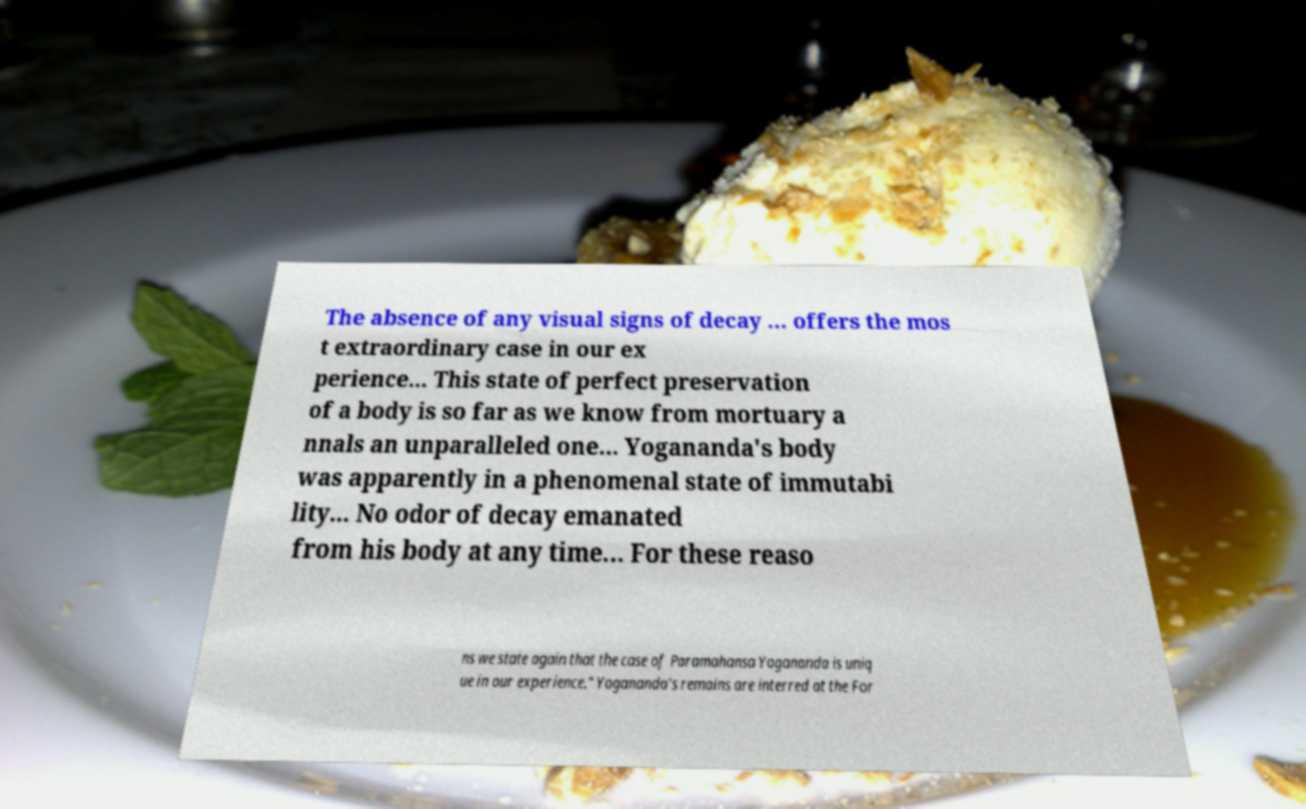Can you read and provide the text displayed in the image?This photo seems to have some interesting text. Can you extract and type it out for me? The absence of any visual signs of decay … offers the mos t extraordinary case in our ex perience... This state of perfect preservation of a body is so far as we know from mortuary a nnals an unparalleled one... Yogananda's body was apparently in a phenomenal state of immutabi lity... No odor of decay emanated from his body at any time... For these reaso ns we state again that the case of Paramahansa Yogananda is uniq ue in our experience." Yogananda's remains are interred at the For 